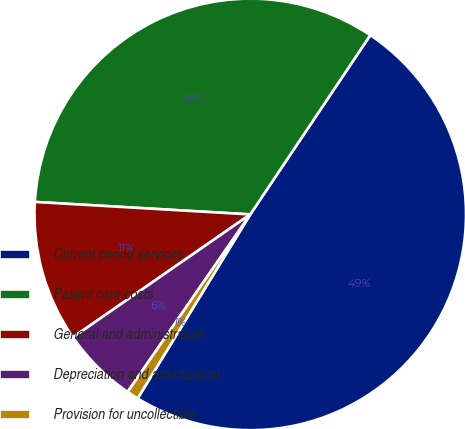Convert chart. <chart><loc_0><loc_0><loc_500><loc_500><pie_chart><fcel>Current period services<fcel>Patient care costs<fcel>General and administrative<fcel>Depreciation and amortization<fcel>Provision for uncollectible<nl><fcel>49.35%<fcel>33.47%<fcel>10.57%<fcel>5.73%<fcel>0.88%<nl></chart> 